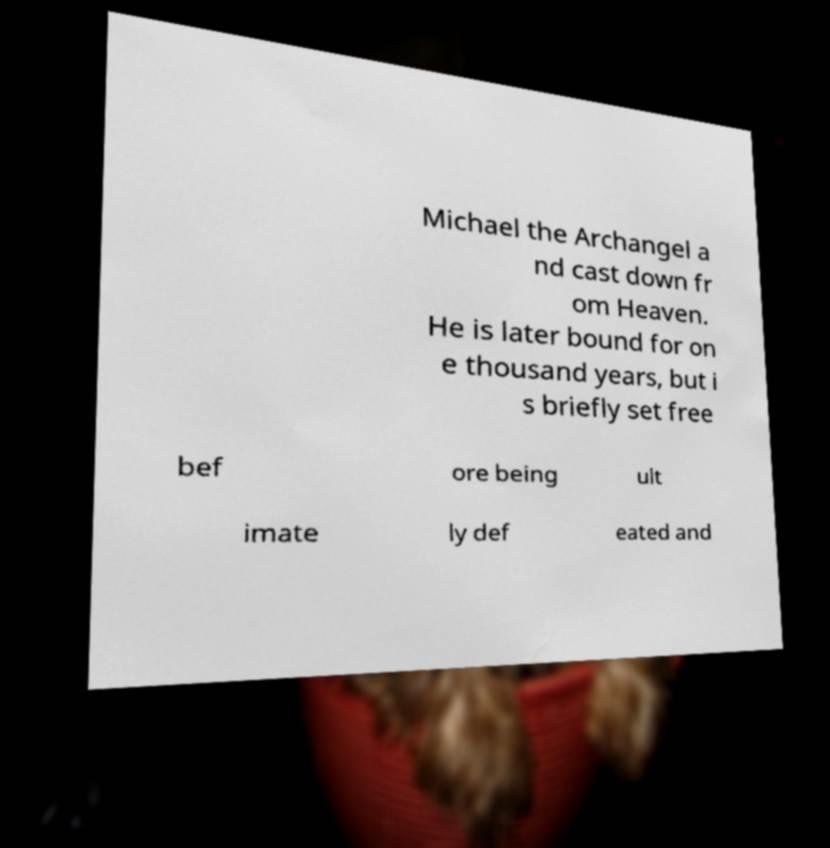Please read and relay the text visible in this image. What does it say? Michael the Archangel a nd cast down fr om Heaven. He is later bound for on e thousand years, but i s briefly set free bef ore being ult imate ly def eated and 